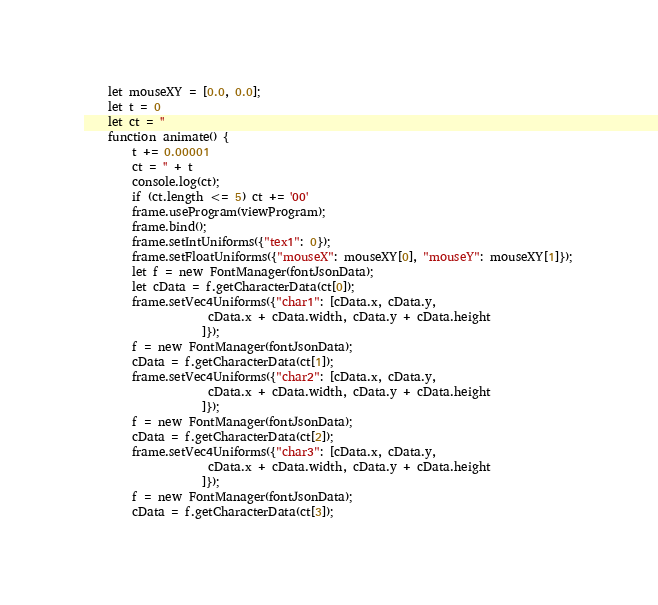<code> <loc_0><loc_0><loc_500><loc_500><_JavaScript_>    let mouseXY = [0.0, 0.0];
    let t = 0
    let ct = ''
    function animate() {
        t += 0.00001
        ct = '' + t
        console.log(ct);
        if (ct.length <= 5) ct += '00'
        frame.useProgram(viewProgram);
        frame.bind();
        frame.setIntUniforms({"tex1": 0});
        frame.setFloatUniforms({"mouseX": mouseXY[0], "mouseY": mouseXY[1]});
        let f = new FontManager(fontJsonData);
        let cData = f.getCharacterData(ct[0]);
        frame.setVec4Uniforms({"char1": [cData.x, cData.y,
					 cData.x + cData.width, cData.y + cData.height
					]});
        f = new FontManager(fontJsonData);
        cData = f.getCharacterData(ct[1]);
        frame.setVec4Uniforms({"char2": [cData.x, cData.y,
					 cData.x + cData.width, cData.y + cData.height
					]});
        f = new FontManager(fontJsonData);
        cData = f.getCharacterData(ct[2]);
        frame.setVec4Uniforms({"char3": [cData.x, cData.y,
					 cData.x + cData.width, cData.y + cData.height
					]});
        f = new FontManager(fontJsonData);
        cData = f.getCharacterData(ct[3]);</code> 